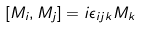Convert formula to latex. <formula><loc_0><loc_0><loc_500><loc_500>[ M _ { i } , M _ { j } ] = i \epsilon _ { i j k } M _ { k } \\</formula> 